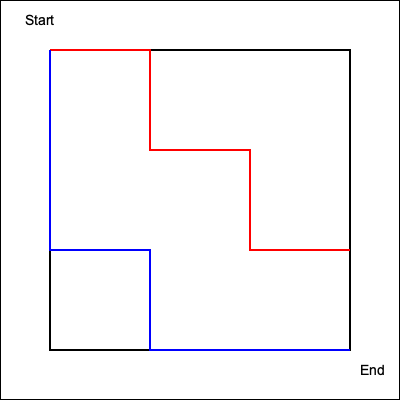In this game level layout, two possible paths from start to end are shown: a red path and a blue path. Which path represents the shortest route through the level, and by how many grid units is it shorter? To determine the shortest path and calculate the difference in length, we need to count the grid units for each path:

1. Red path:
   - Right: 3 units
   - Down: 1 unit
   - Right: 1 unit
   - Down: 1 unit
   - Right: 1 unit
   Total: 7 units

2. Blue path:
   - Down: 2 units
   - Right: 1 unit
   - Down: 1 unit
   - Right: 2 units
   Total: 6 units

The blue path is shorter than the red path.

To calculate the difference:
$$ \text{Difference} = \text{Red path length} - \text{Blue path length} $$
$$ \text{Difference} = 7 - 6 = 1 \text{ unit} $$

Therefore, the blue path is the shortest route and is 1 grid unit shorter than the red path.
Answer: Blue path; 1 unit shorter 